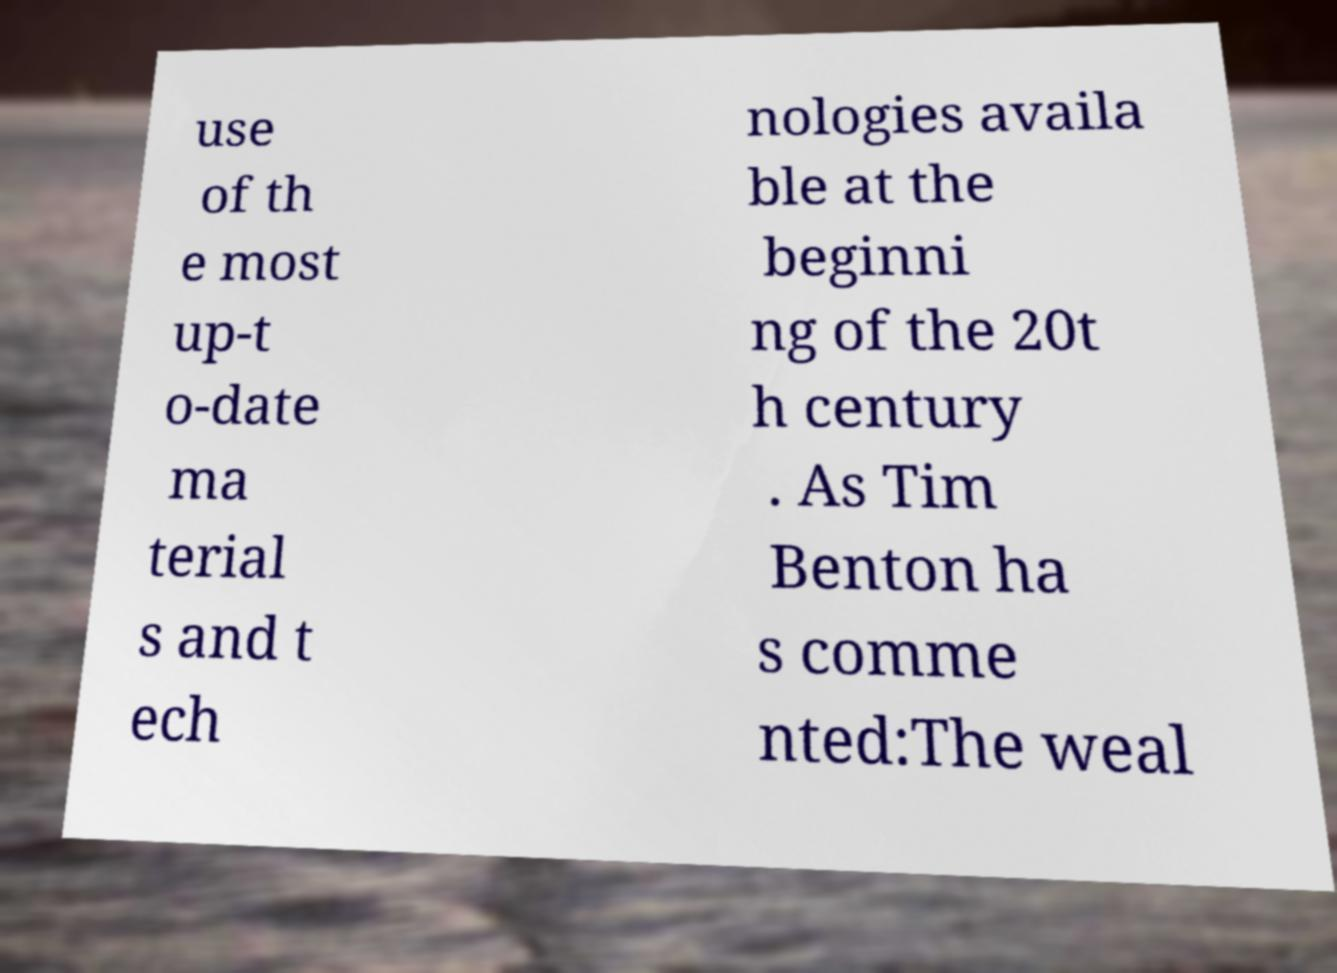Could you assist in decoding the text presented in this image and type it out clearly? use of th e most up-t o-date ma terial s and t ech nologies availa ble at the beginni ng of the 20t h century . As Tim Benton ha s comme nted:The weal 